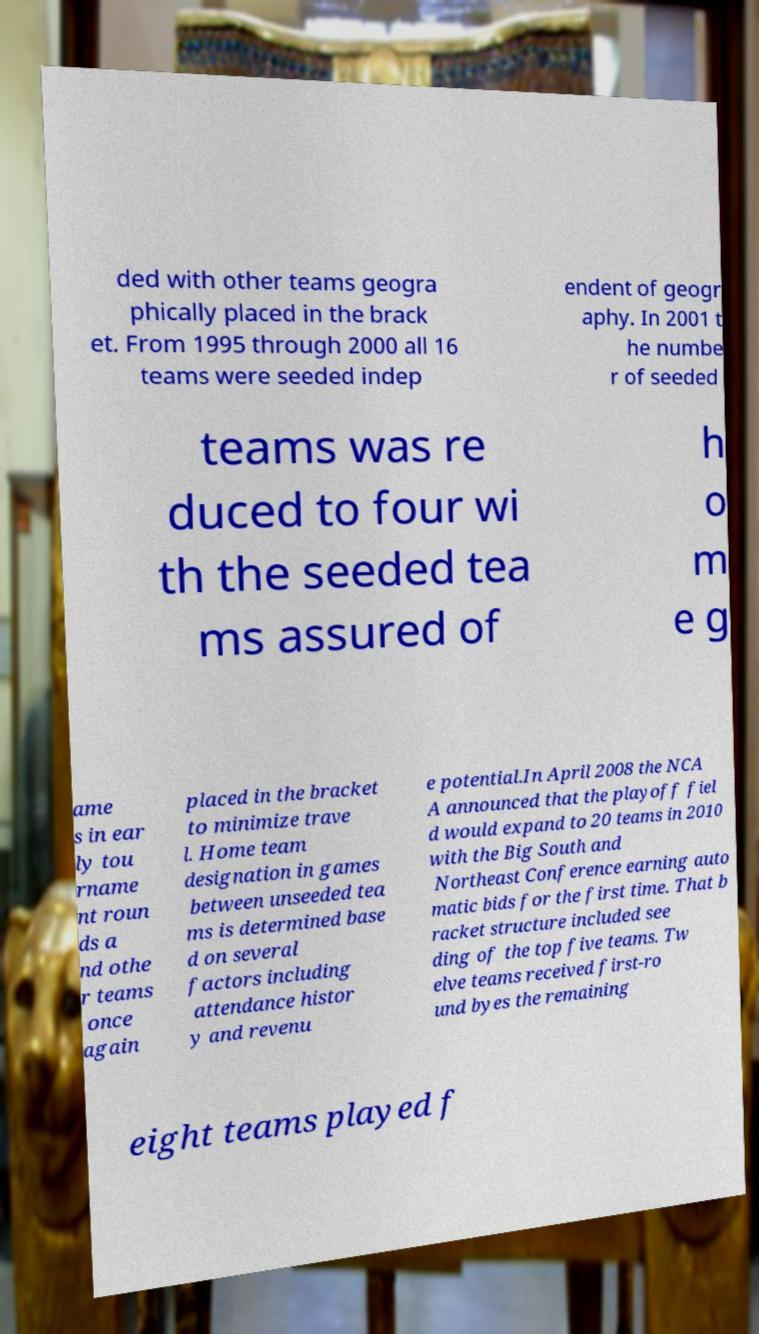There's text embedded in this image that I need extracted. Can you transcribe it verbatim? ded with other teams geogra phically placed in the brack et. From 1995 through 2000 all 16 teams were seeded indep endent of geogr aphy. In 2001 t he numbe r of seeded teams was re duced to four wi th the seeded tea ms assured of h o m e g ame s in ear ly tou rname nt roun ds a nd othe r teams once again placed in the bracket to minimize trave l. Home team designation in games between unseeded tea ms is determined base d on several factors including attendance histor y and revenu e potential.In April 2008 the NCA A announced that the playoff fiel d would expand to 20 teams in 2010 with the Big South and Northeast Conference earning auto matic bids for the first time. That b racket structure included see ding of the top five teams. Tw elve teams received first-ro und byes the remaining eight teams played f 